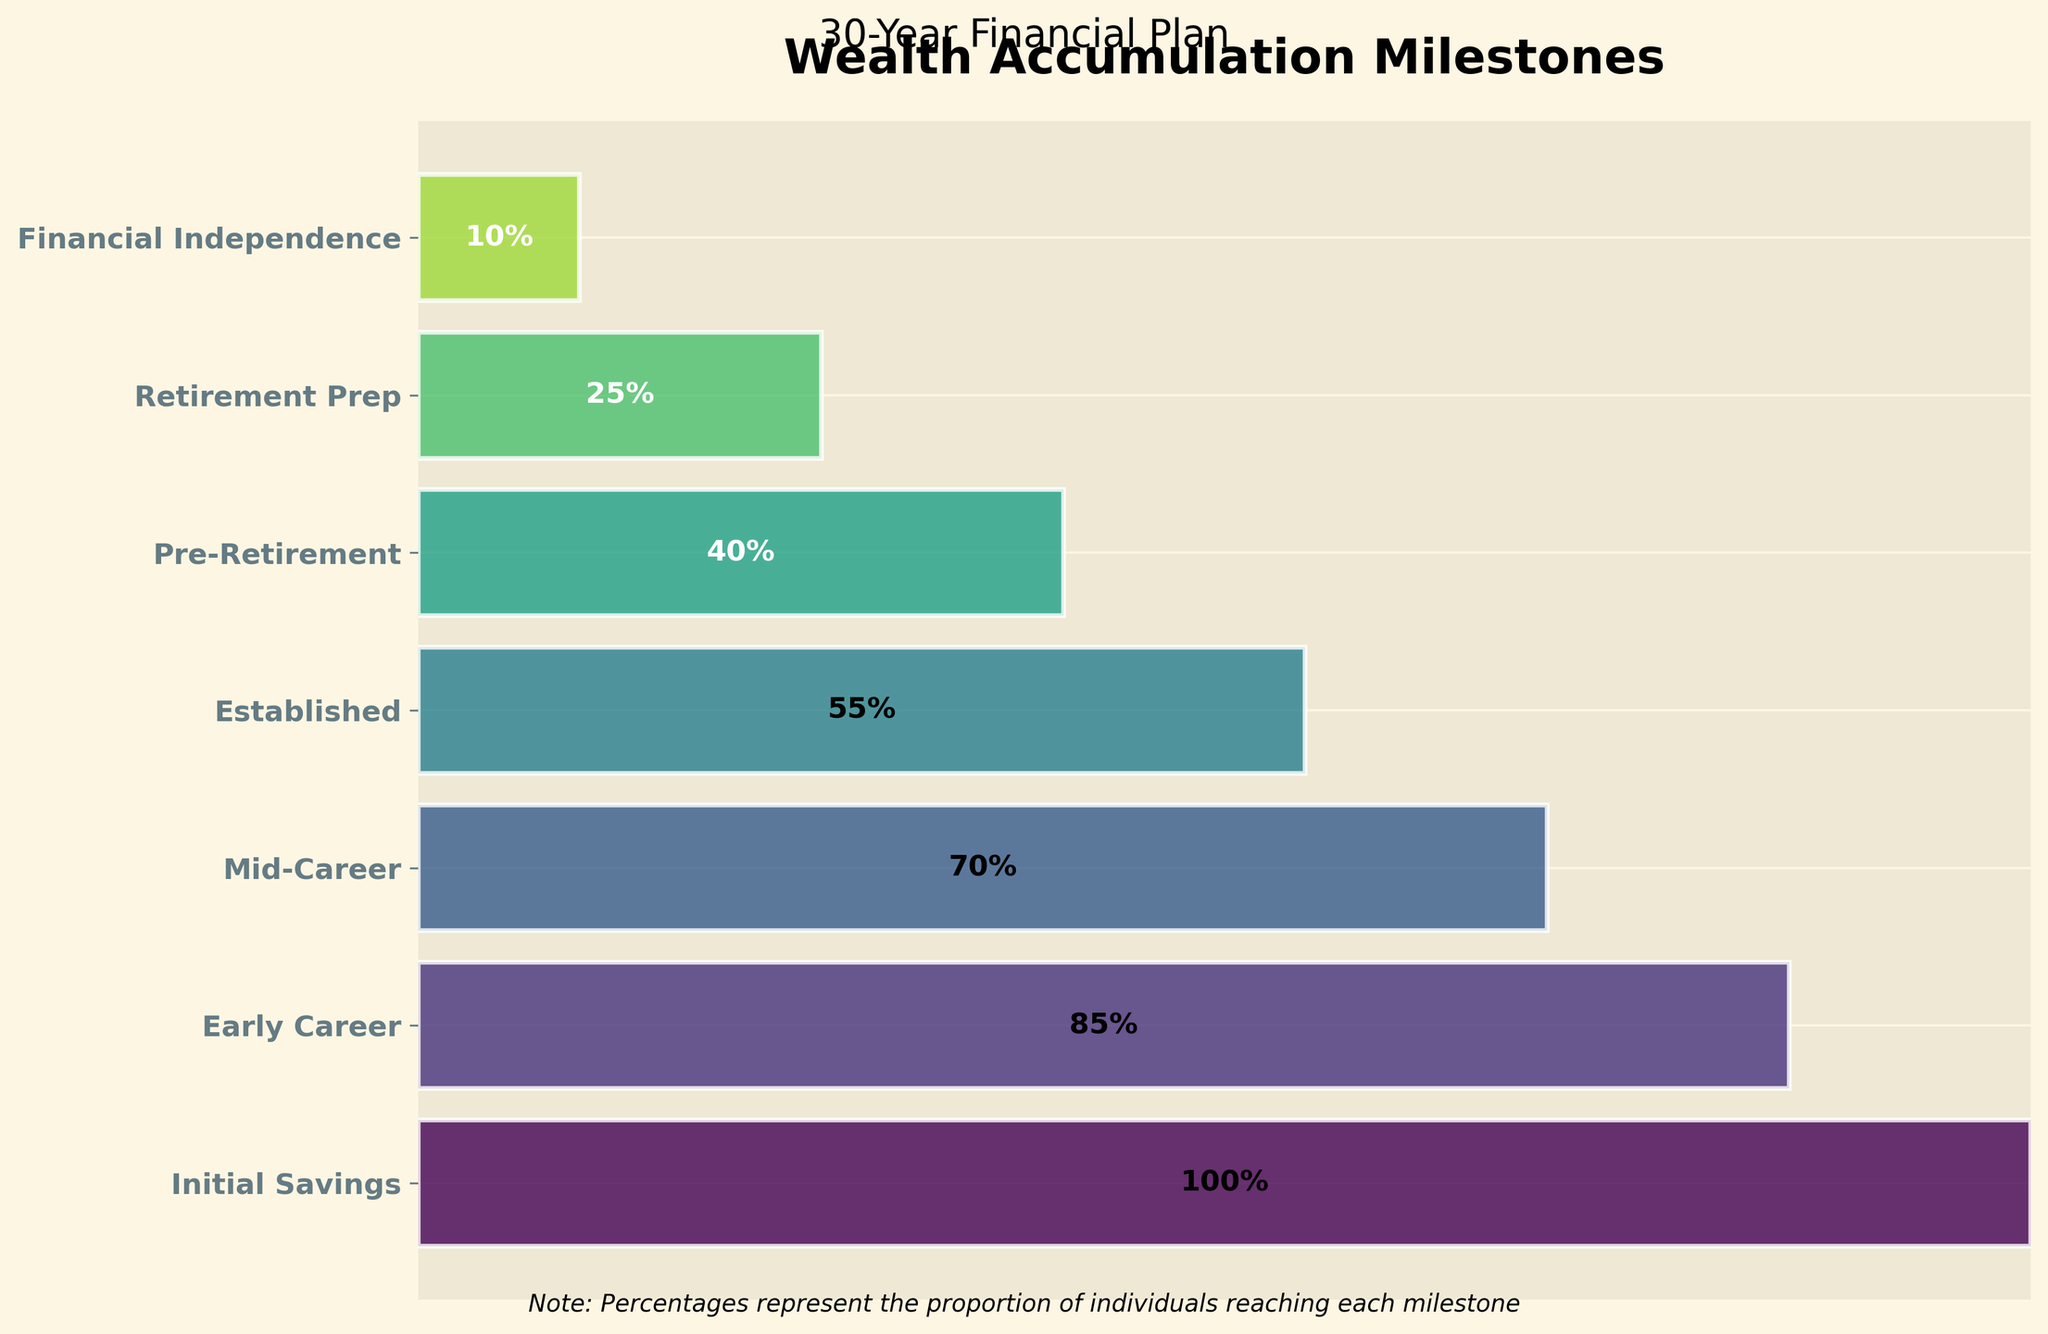What is the title of the chart? The title is displayed prominently at the top of the chart and is labeled "Wealth Accumulation Milestones".
Answer: Wealth Accumulation Milestones What percentage of individuals reach the "Home Ownership" milestone? The percentage next to the "Home Ownership" stage on the y-axis shows 70%.
Answer: 70% Which milestone stage has the highest percentage of individuals reaching it? The chart shows that the first milestone stage, "Emergency Fund Established", has the highest percentage, which is 100%.
Answer: Emergency Fund Established How many milestone stages are represented in the chart? Counting the number of horizontal bars or labels on the y-axis, we see there are 7 stages in the chart.
Answer: 7 What is the difference in percentage between the "Children's Education Fund" and "Retirement Portfolio at 80% Goal" milestones? The percentage for "Children's Education Fund" is 55% and for "Retirement Portfolio at 80% Goal" is 25%. The difference is 55% - 25% = 30%.
Answer: 30% What milestone corresponds to a percentage of 40%? The milestone associated with 40% is labeled "Retirement Portfolio at 50% Goal" on the y-axis.
Answer: Retirement Portfolio at 50% Goal How many stages have a percentage above 50%? Stages with percentages above 50% are: Emergency Fund Established (100%), Debt-Free (85%), Home Ownership (70%), and Children's Education Fund (55%). Counting these gives 4 stages.
Answer: 4 Which milestone stage has the lowest percentage of individuals reaching it? The chart shows that the last milestone stage, "Retirement Portfolio Fully Funded", has the lowest percentage, which is 10%.
Answer: Retirement Portfolio Fully Funded Are there more stages with percentages higher than 50% or lower than 50%? Stages with percentages above 50% are 4: Emergency Fund Established, Debt-Free, Home Ownership, Children's Education Fund. Stages below 50% are 3: Retirement Portfolio at 50% Goal, Retirement Portfolio at 80% Goal, Retirement Portfolio Fully Funded. So, there are more stages above 50%.
Answer: More stages above 50% Calculate the average percentage for all milestones. Sum the percentages: 100% + 85% + 70% + 55% + 40% + 25% + 10% = 385%. There are 7 stages, so the average is 385% / 7 = 55%.
Answer: 55% 